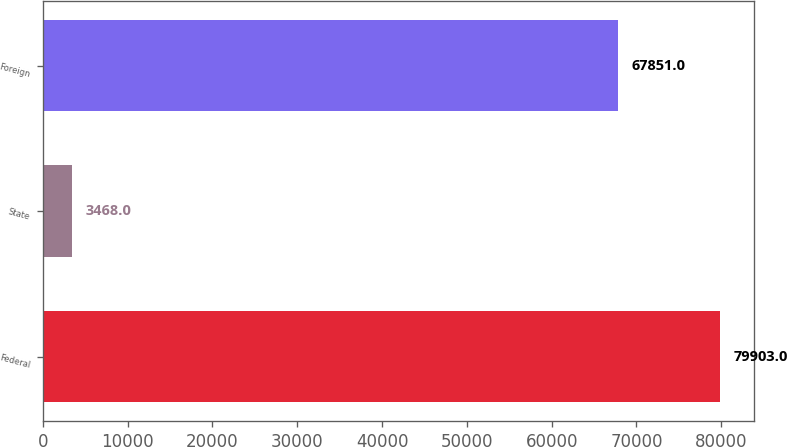Convert chart. <chart><loc_0><loc_0><loc_500><loc_500><bar_chart><fcel>Federal<fcel>State<fcel>Foreign<nl><fcel>79903<fcel>3468<fcel>67851<nl></chart> 